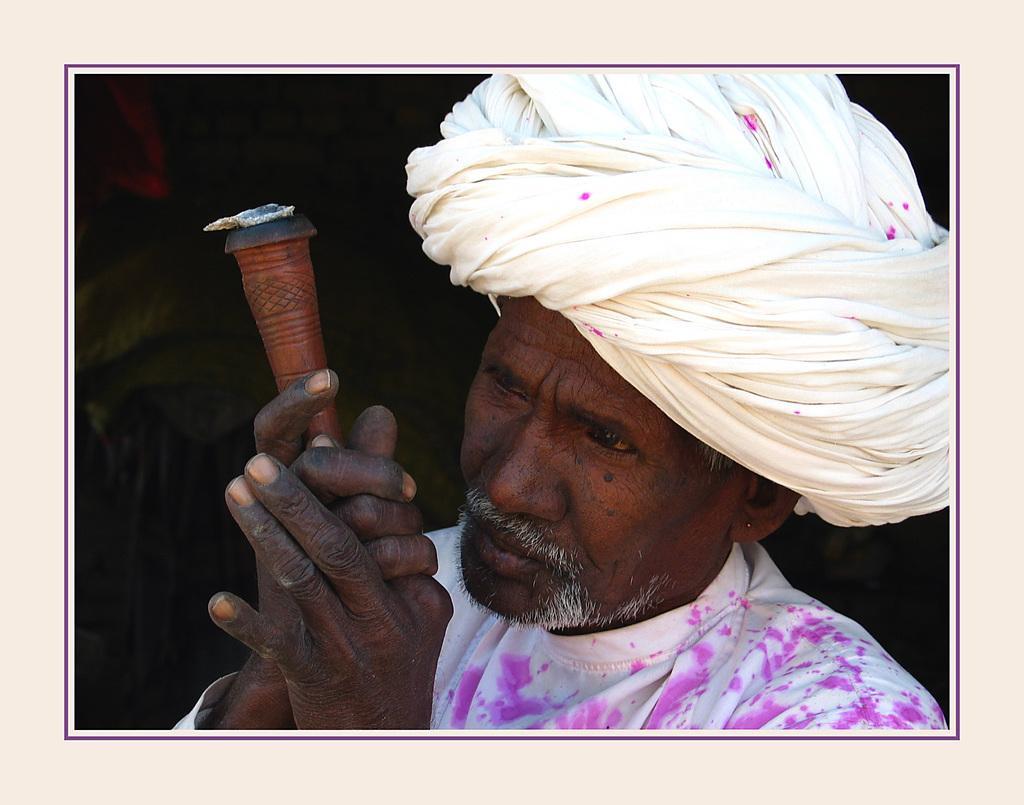Could you give a brief overview of what you see in this image? In this picture, we can see a photo frame. In this image, in the middle, we can see a man holding an object in his hand. In the background, we can see black color. 